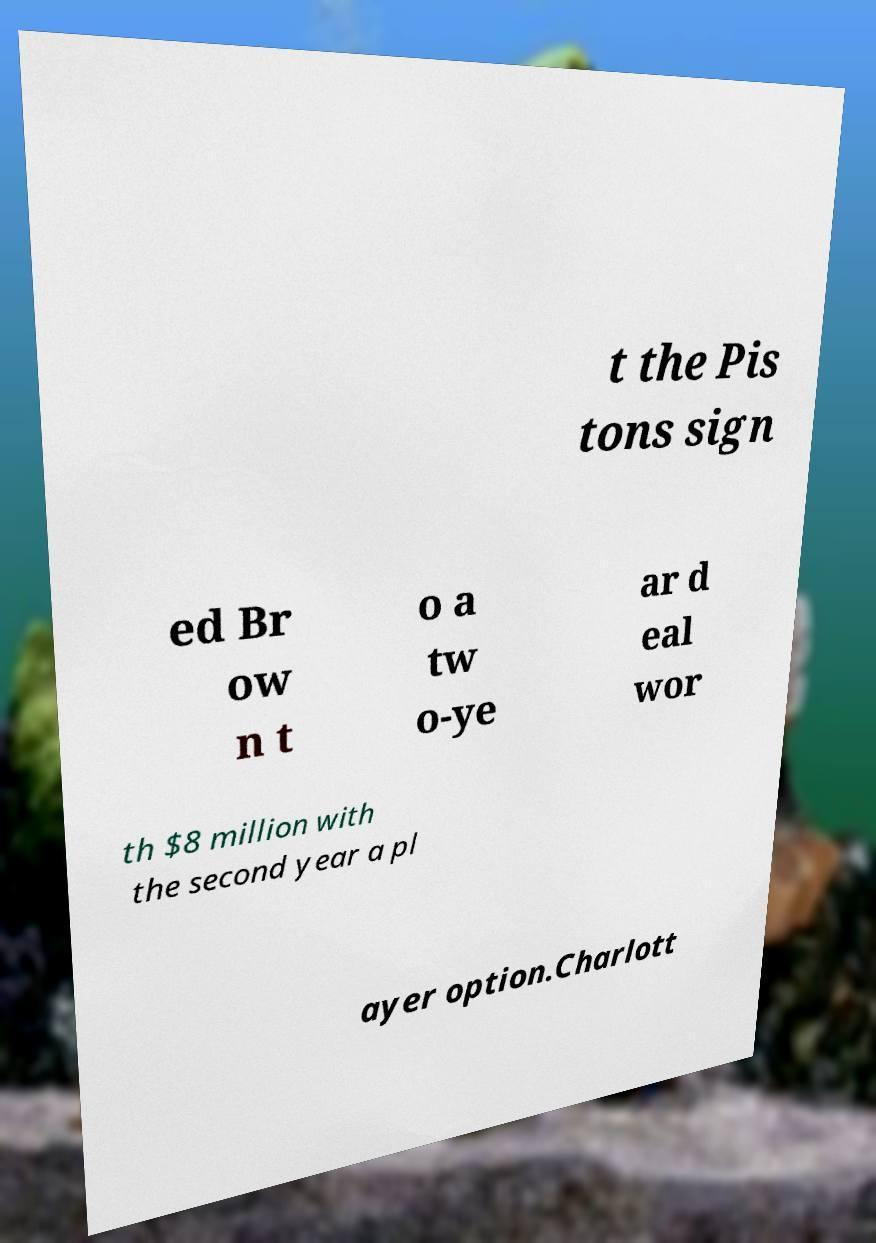Can you accurately transcribe the text from the provided image for me? t the Pis tons sign ed Br ow n t o a tw o-ye ar d eal wor th $8 million with the second year a pl ayer option.Charlott 